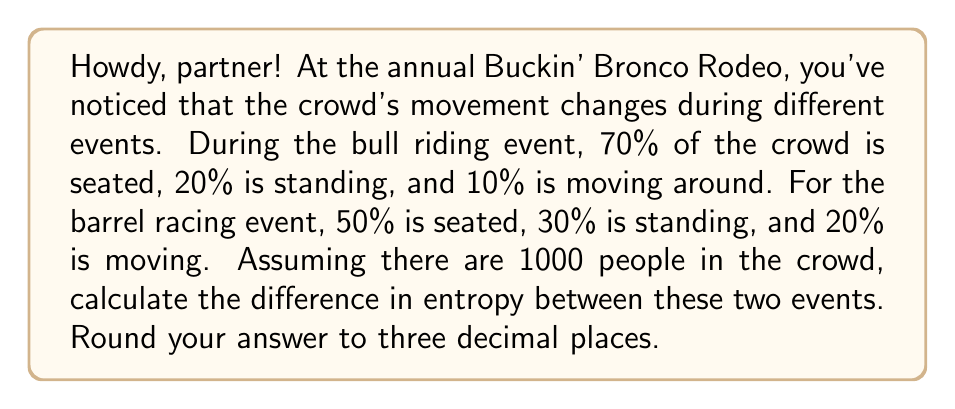Can you answer this question? Let's approach this step-by-step using the concept of Shannon entropy:

1) The entropy formula is:
   $$S = -k\sum_{i} p_i \ln(p_i)$$
   where $k$ is Boltzmann's constant (which we'll take as 1 for simplicity) and $p_i$ is the probability of each state.

2) For the bull riding event:
   $p_1 = 0.7$ (seated), $p_2 = 0.2$ (standing), $p_3 = 0.1$ (moving)
   
   $$S_{bull} = -[0.7\ln(0.7) + 0.2\ln(0.2) + 0.1\ln(0.1)]$$

3) For the barrel racing event:
   $p_1 = 0.5$ (seated), $p_2 = 0.3$ (standing), $p_3 = 0.2$ (moving)
   
   $$S_{barrel} = -[0.5\ln(0.5) + 0.3\ln(0.3) + 0.2\ln(0.2)]$$

4) Calculate each entropy:
   $$S_{bull} = -[0.7(-0.3567) + 0.2(-1.6094) + 0.1(-2.3026)] = 0.8018$$
   $$S_{barrel} = -[0.5(-0.6931) + 0.3(-1.2040) + 0.2(-1.6094)] = 1.0297$$

5) Find the difference:
   $$\Delta S = S_{barrel} - S_{bull} = 1.0297 - 0.8018 = 0.2279$$

6) Rounding to three decimal places: 0.228
Answer: 0.228 